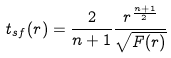Convert formula to latex. <formula><loc_0><loc_0><loc_500><loc_500>t _ { s f } ( r ) = \frac { 2 } { n + 1 } \frac { r ^ { \frac { n + 1 } { 2 } } } { \sqrt { F ( r ) } }</formula> 